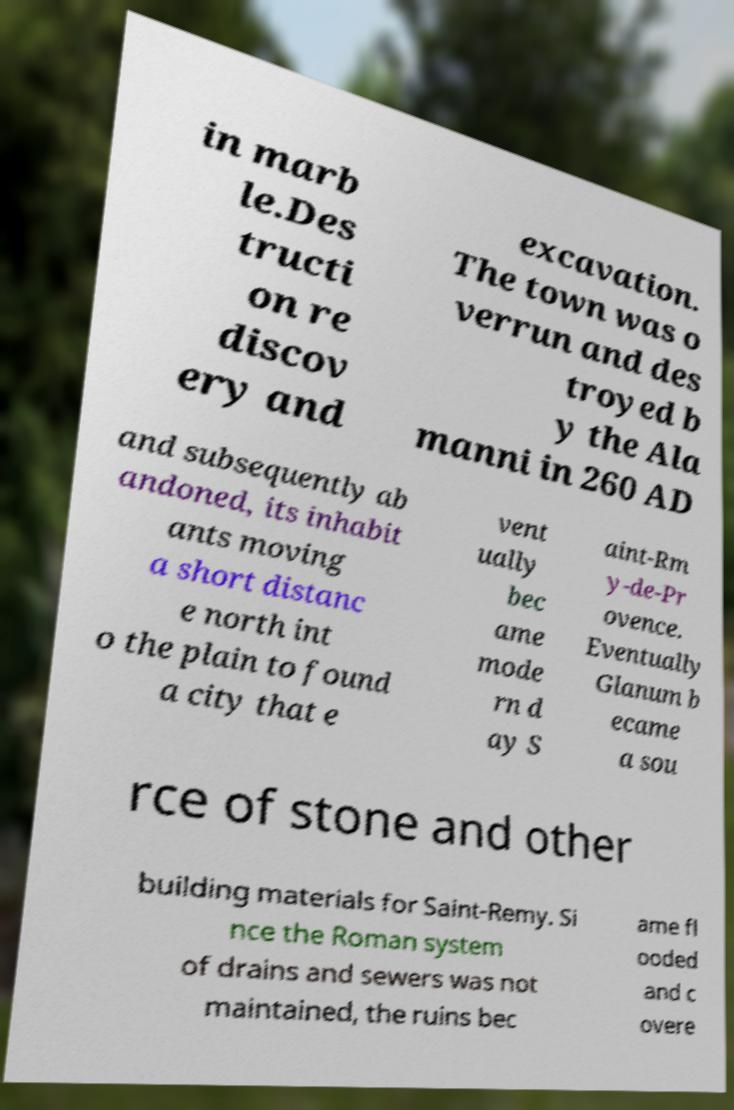There's text embedded in this image that I need extracted. Can you transcribe it verbatim? in marb le.Des tructi on re discov ery and excavation. The town was o verrun and des troyed b y the Ala manni in 260 AD and subsequently ab andoned, its inhabit ants moving a short distanc e north int o the plain to found a city that e vent ually bec ame mode rn d ay S aint-Rm y-de-Pr ovence. Eventually Glanum b ecame a sou rce of stone and other building materials for Saint-Remy. Si nce the Roman system of drains and sewers was not maintained, the ruins bec ame fl ooded and c overe 